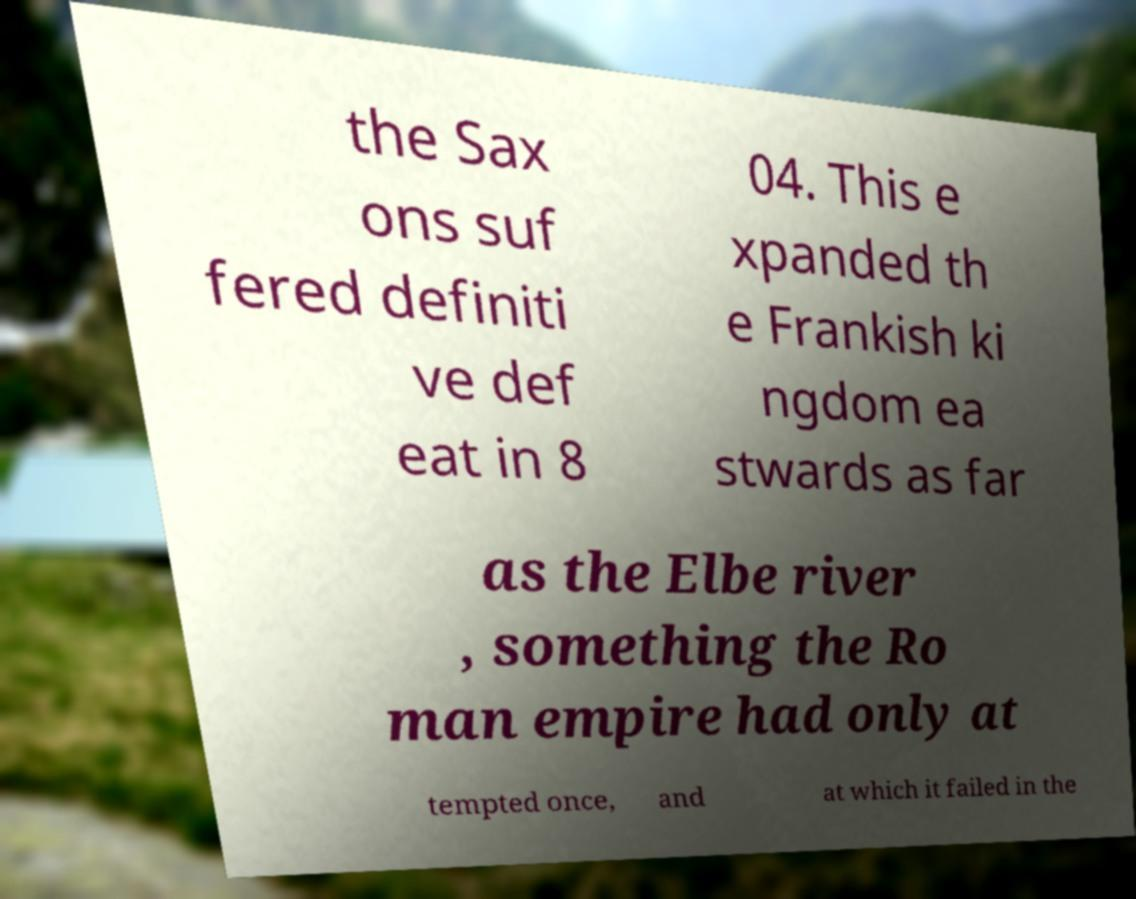What messages or text are displayed in this image? I need them in a readable, typed format. the Sax ons suf fered definiti ve def eat in 8 04. This e xpanded th e Frankish ki ngdom ea stwards as far as the Elbe river , something the Ro man empire had only at tempted once, and at which it failed in the 